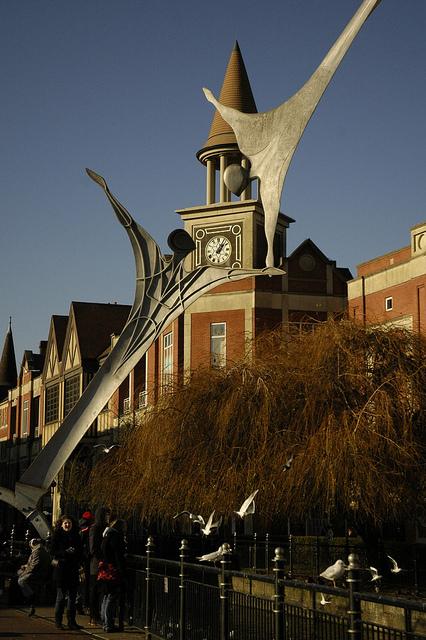Is there a clock on the building?
Keep it brief. Yes. Is the tree an evergreen?
Quick response, please. No. What color is the clock?
Quick response, please. White. 